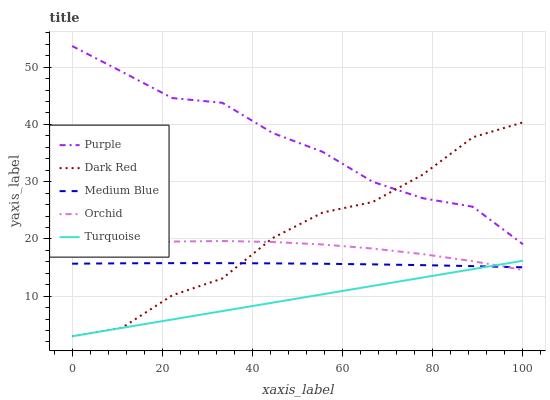Does Turquoise have the minimum area under the curve?
Answer yes or no. Yes. Does Purple have the maximum area under the curve?
Answer yes or no. Yes. Does Dark Red have the minimum area under the curve?
Answer yes or no. No. Does Dark Red have the maximum area under the curve?
Answer yes or no. No. Is Turquoise the smoothest?
Answer yes or no. Yes. Is Dark Red the roughest?
Answer yes or no. Yes. Is Dark Red the smoothest?
Answer yes or no. No. Is Turquoise the roughest?
Answer yes or no. No. Does Dark Red have the lowest value?
Answer yes or no. Yes. Does Medium Blue have the lowest value?
Answer yes or no. No. Does Purple have the highest value?
Answer yes or no. Yes. Does Dark Red have the highest value?
Answer yes or no. No. Is Orchid less than Purple?
Answer yes or no. Yes. Is Purple greater than Orchid?
Answer yes or no. Yes. Does Medium Blue intersect Orchid?
Answer yes or no. Yes. Is Medium Blue less than Orchid?
Answer yes or no. No. Is Medium Blue greater than Orchid?
Answer yes or no. No. Does Orchid intersect Purple?
Answer yes or no. No. 